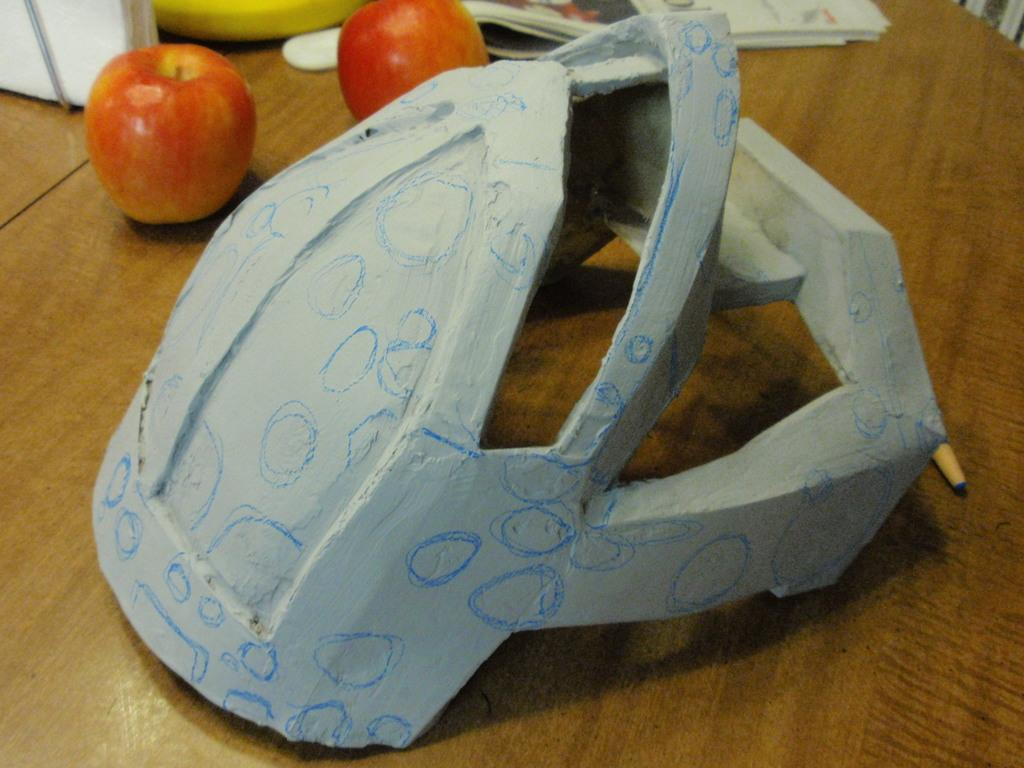What material is the helmet made of in the image? The helmet in the image is made of wood. What type of fruit can be seen on the table in the image? Two apples are present on the table in the image. What song is being sung by the helmet in the image? There is no indication in the image that the helmet is singing a song, as it is an inanimate object. 